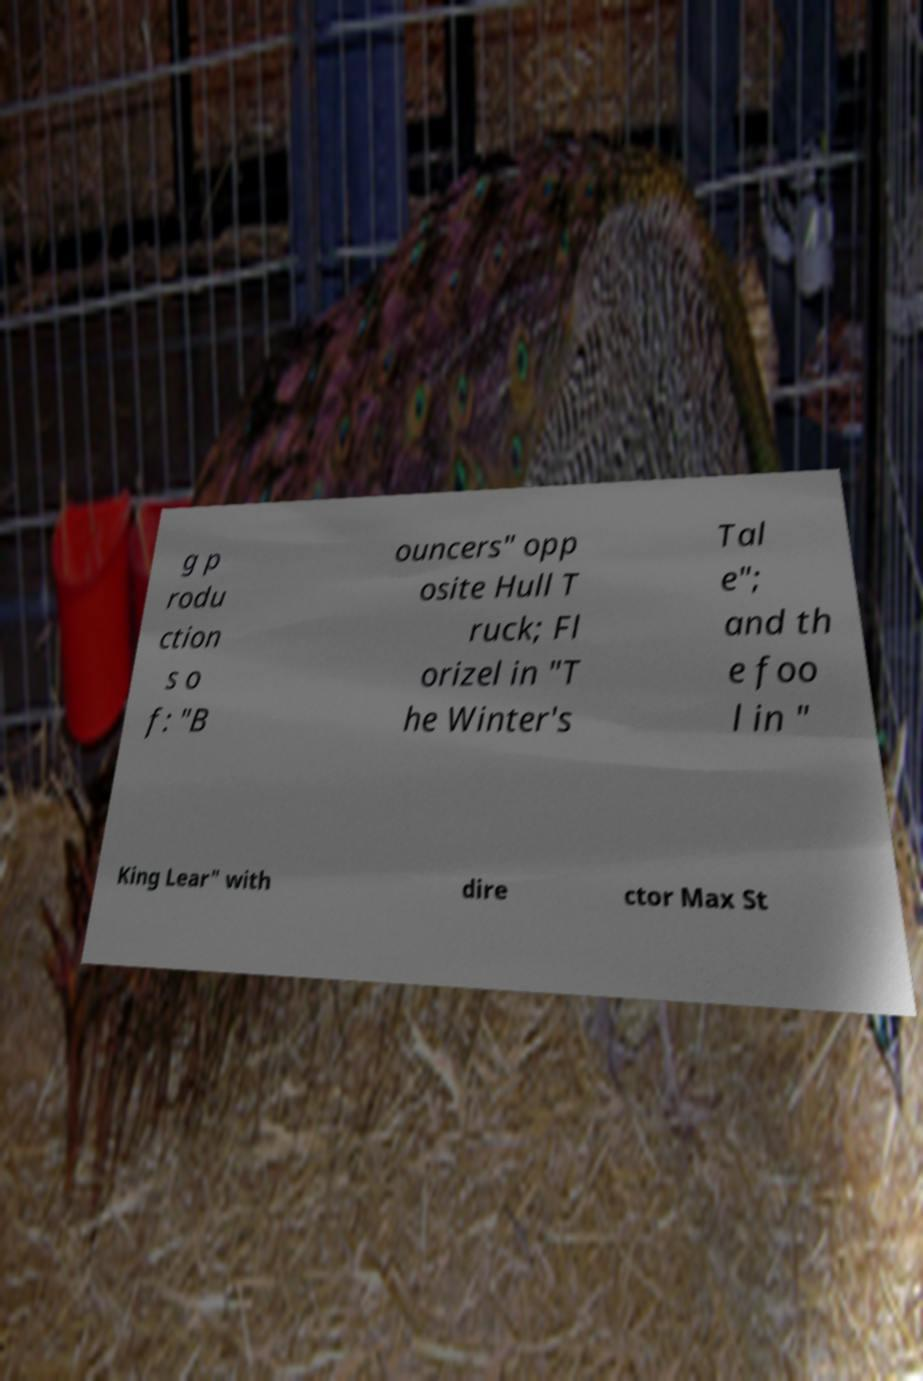Could you extract and type out the text from this image? g p rodu ction s o f: "B ouncers" opp osite Hull T ruck; Fl orizel in "T he Winter's Tal e"; and th e foo l in " King Lear" with dire ctor Max St 